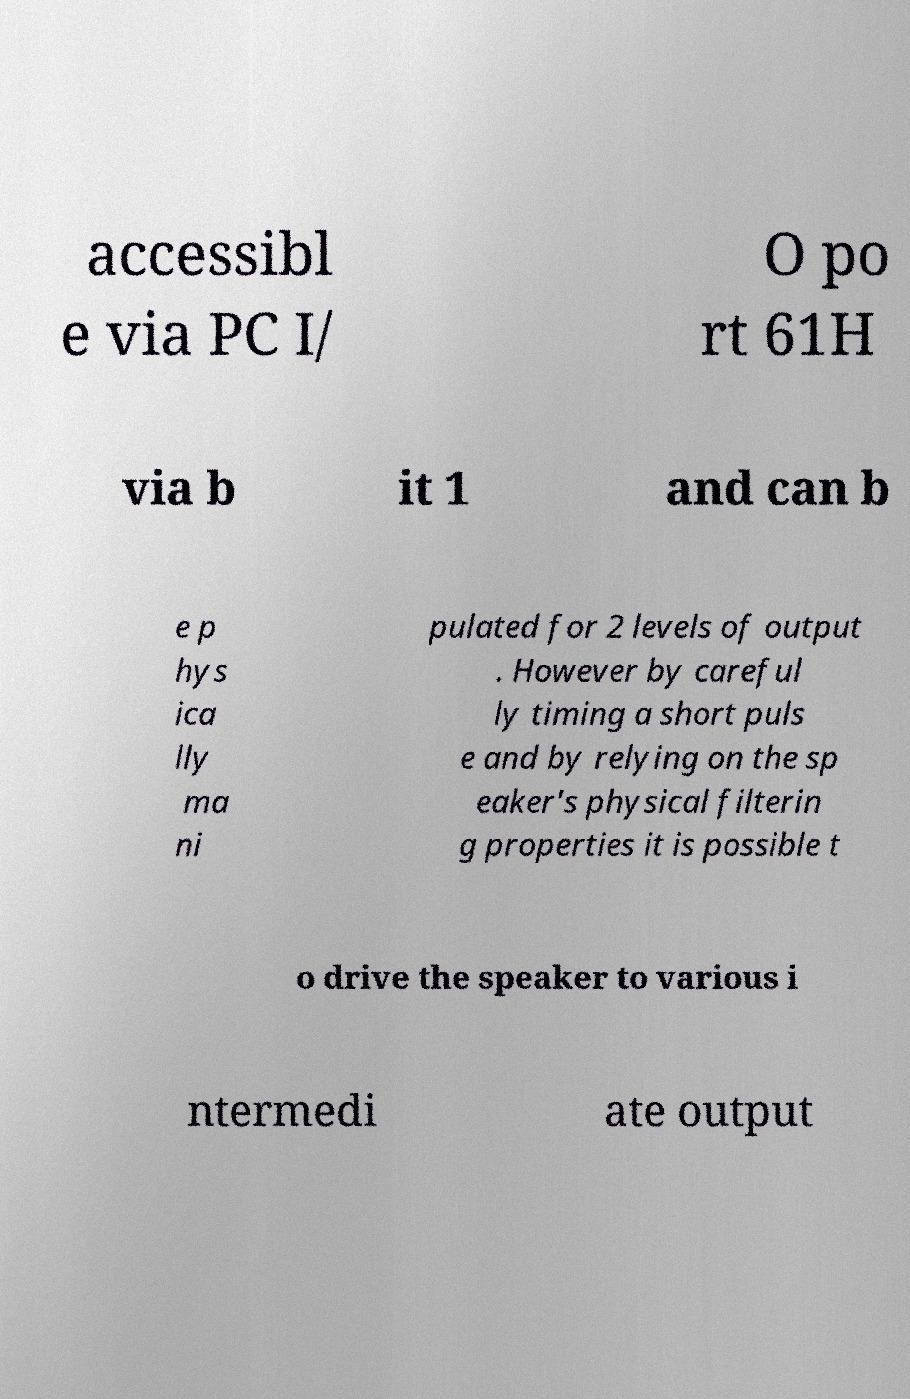Please read and relay the text visible in this image. What does it say? accessibl e via PC I/ O po rt 61H via b it 1 and can b e p hys ica lly ma ni pulated for 2 levels of output . However by careful ly timing a short puls e and by relying on the sp eaker's physical filterin g properties it is possible t o drive the speaker to various i ntermedi ate output 